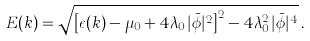Convert formula to latex. <formula><loc_0><loc_0><loc_500><loc_500>E ( { k } ) = \sqrt { \left [ \epsilon ( { k } ) - \mu _ { 0 } + 4 \lambda _ { 0 } | \bar { \phi } | ^ { 2 } \right ] ^ { 2 } - 4 \lambda _ { 0 } ^ { 2 } | \bar { \phi } | ^ { 4 } } \, .</formula> 